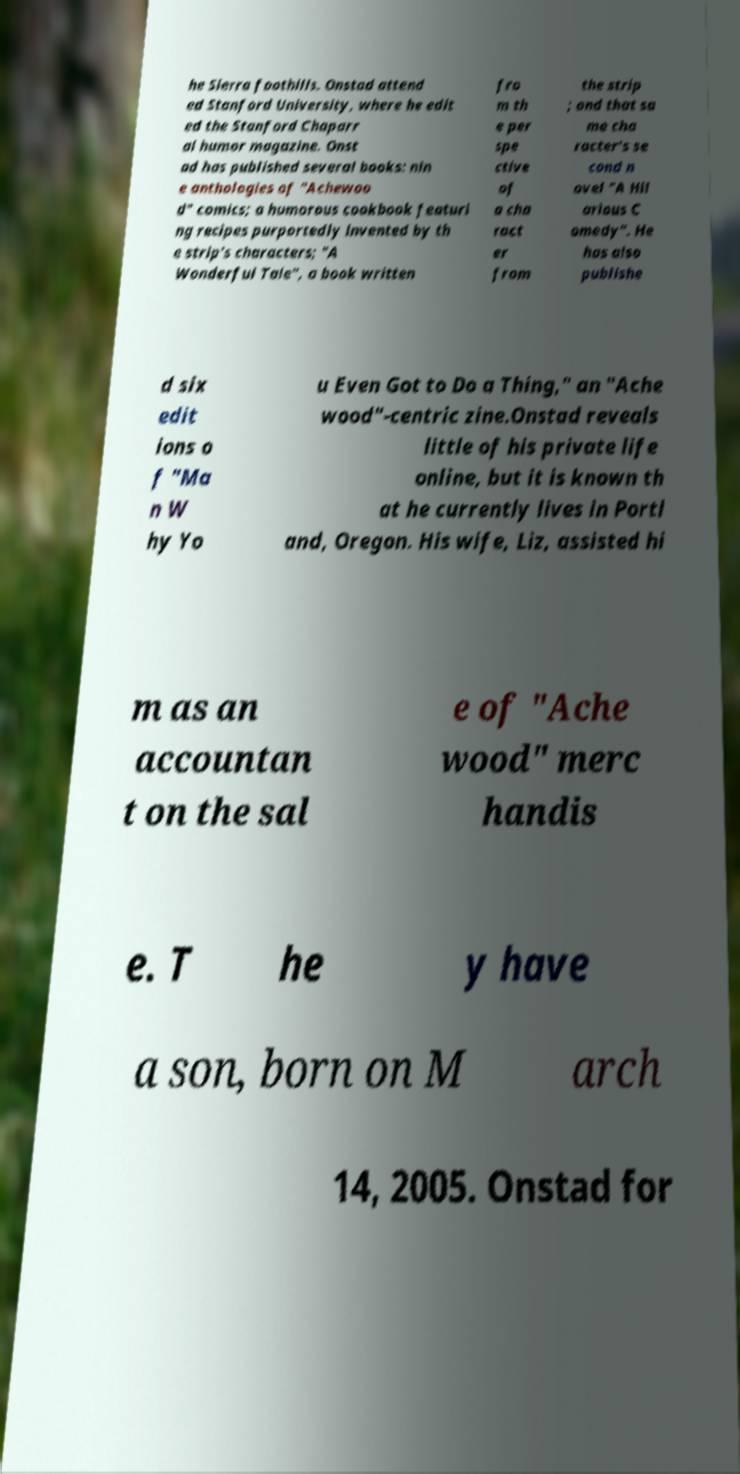For documentation purposes, I need the text within this image transcribed. Could you provide that? he Sierra foothills. Onstad attend ed Stanford University, where he edit ed the Stanford Chaparr al humor magazine. Onst ad has published several books: nin e anthologies of "Achewoo d" comics; a humorous cookbook featuri ng recipes purportedly invented by th e strip's characters; "A Wonderful Tale", a book written fro m th e per spe ctive of a cha ract er from the strip ; and that sa me cha racter's se cond n ovel "A Hil arious C omedy". He has also publishe d six edit ions o f "Ma n W hy Yo u Even Got to Do a Thing," an "Ache wood"-centric zine.Onstad reveals little of his private life online, but it is known th at he currently lives in Portl and, Oregon. His wife, Liz, assisted hi m as an accountan t on the sal e of "Ache wood" merc handis e. T he y have a son, born on M arch 14, 2005. Onstad for 